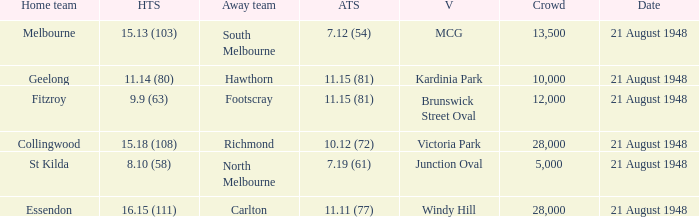When the Away team is south melbourne, what's the Home team score? 15.13 (103). 